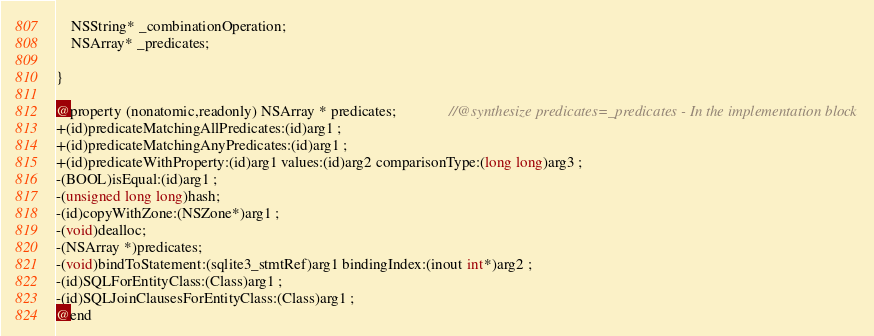<code> <loc_0><loc_0><loc_500><loc_500><_C_>	NSString* _combinationOperation;
	NSArray* _predicates;

}

@property (nonatomic,readonly) NSArray * predicates;              //@synthesize predicates=_predicates - In the implementation block
+(id)predicateMatchingAllPredicates:(id)arg1 ;
+(id)predicateMatchingAnyPredicates:(id)arg1 ;
+(id)predicateWithProperty:(id)arg1 values:(id)arg2 comparisonType:(long long)arg3 ;
-(BOOL)isEqual:(id)arg1 ;
-(unsigned long long)hash;
-(id)copyWithZone:(NSZone*)arg1 ;
-(void)dealloc;
-(NSArray *)predicates;
-(void)bindToStatement:(sqlite3_stmtRef)arg1 bindingIndex:(inout int*)arg2 ;
-(id)SQLForEntityClass:(Class)arg1 ;
-(id)SQLJoinClausesForEntityClass:(Class)arg1 ;
@end

</code> 